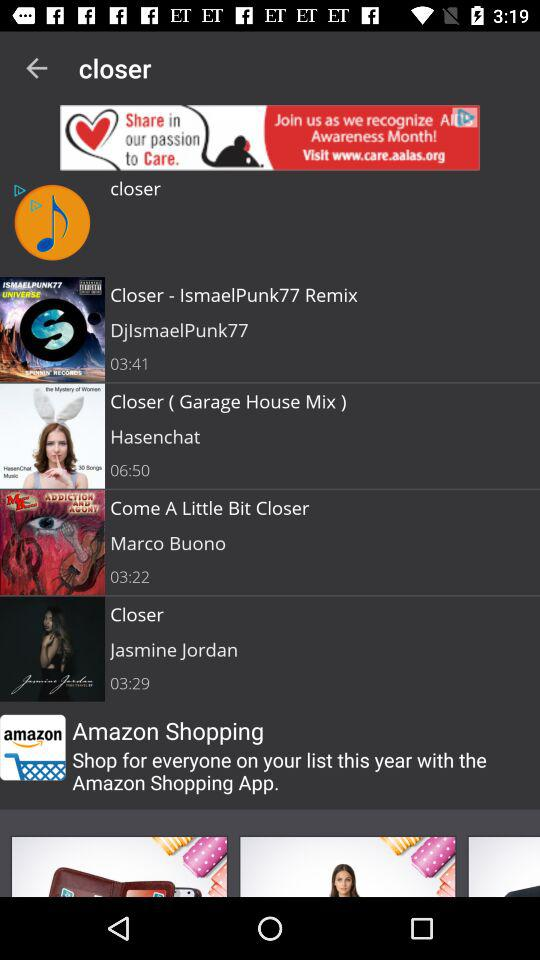What is the duration of the song "Come A Little Bit Closer"? The duration is 3 minutes 22 seconds. 